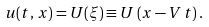Convert formula to latex. <formula><loc_0><loc_0><loc_500><loc_500>u ( t , \, x ) = U ( \xi ) \equiv U \left ( x - V \, t \right ) .</formula> 